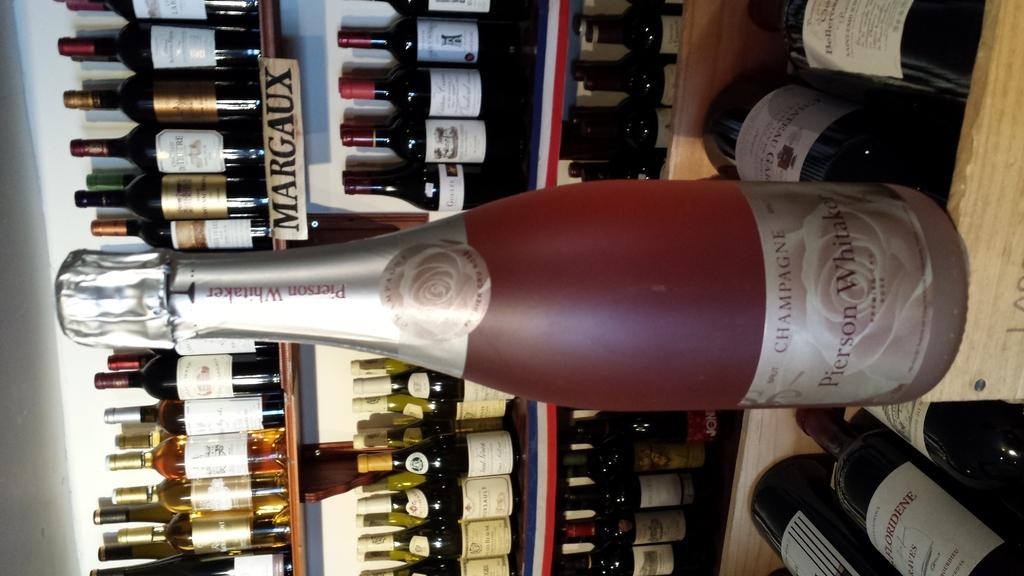Provide a one-sentence caption for the provided image. A bottle of champagne with a reddish color to it. 